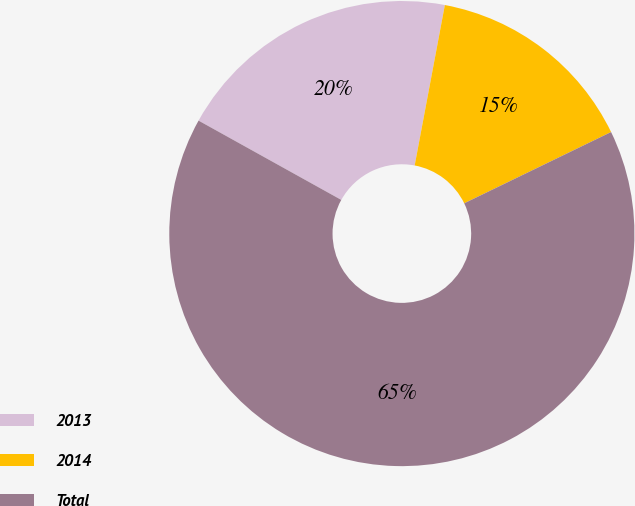Convert chart. <chart><loc_0><loc_0><loc_500><loc_500><pie_chart><fcel>2013<fcel>2014<fcel>Total<nl><fcel>19.89%<fcel>14.85%<fcel>65.26%<nl></chart> 